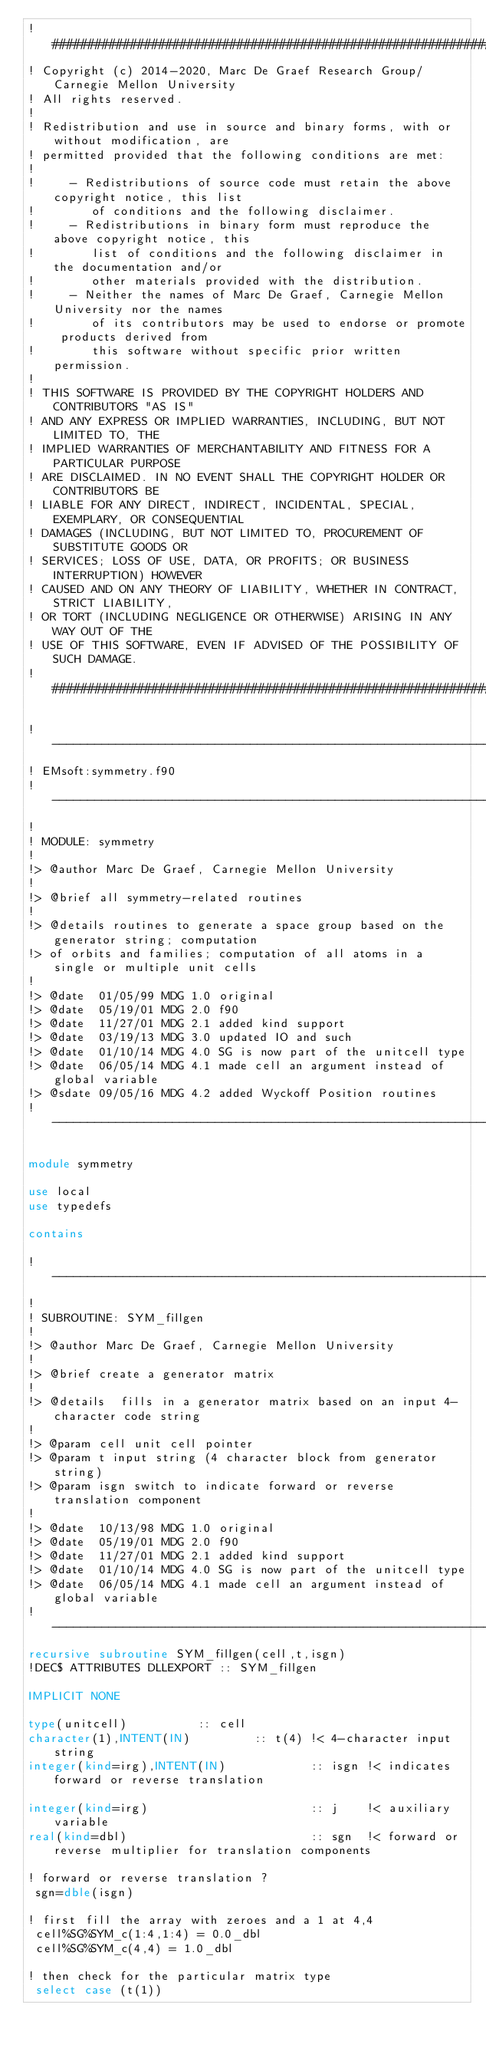<code> <loc_0><loc_0><loc_500><loc_500><_FORTRAN_>! ###################################################################
! Copyright (c) 2014-2020, Marc De Graef Research Group/Carnegie Mellon University
! All rights reserved.
!
! Redistribution and use in source and binary forms, with or without modification, are 
! permitted provided that the following conditions are met:
!
!     - Redistributions of source code must retain the above copyright notice, this list 
!        of conditions and the following disclaimer.
!     - Redistributions in binary form must reproduce the above copyright notice, this 
!        list of conditions and the following disclaimer in the documentation and/or 
!        other materials provided with the distribution.
!     - Neither the names of Marc De Graef, Carnegie Mellon University nor the names 
!        of its contributors may be used to endorse or promote products derived from 
!        this software without specific prior written permission.
!
! THIS SOFTWARE IS PROVIDED BY THE COPYRIGHT HOLDERS AND CONTRIBUTORS "AS IS" 
! AND ANY EXPRESS OR IMPLIED WARRANTIES, INCLUDING, BUT NOT LIMITED TO, THE 
! IMPLIED WARRANTIES OF MERCHANTABILITY AND FITNESS FOR A PARTICULAR PURPOSE 
! ARE DISCLAIMED. IN NO EVENT SHALL THE COPYRIGHT HOLDER OR CONTRIBUTORS BE 
! LIABLE FOR ANY DIRECT, INDIRECT, INCIDENTAL, SPECIAL, EXEMPLARY, OR CONSEQUENTIAL 
! DAMAGES (INCLUDING, BUT NOT LIMITED TO, PROCUREMENT OF SUBSTITUTE GOODS OR 
! SERVICES; LOSS OF USE, DATA, OR PROFITS; OR BUSINESS INTERRUPTION) HOWEVER 
! CAUSED AND ON ANY THEORY OF LIABILITY, WHETHER IN CONTRACT, STRICT LIABILITY, 
! OR TORT (INCLUDING NEGLIGENCE OR OTHERWISE) ARISING IN ANY WAY OUT OF THE 
! USE OF THIS SOFTWARE, EVEN IF ADVISED OF THE POSSIBILITY OF SUCH DAMAGE.
! ###################################################################

!--------------------------------------------------------------------------
! EMsoft:symmetry.f90
!--------------------------------------------------------------------------
!
! MODULE: symmetry
!
!> @author Marc De Graef, Carnegie Mellon University
!
!> @brief all symmetry-related routines
!
!> @details routines to generate a space group based on the generator string; computation
!> of orbits and families; computation of all atoms in a single or multiple unit cells
! 
!> @date  01/05/99 MDG 1.0 original
!> @date  05/19/01 MDG 2.0 f90
!> @date  11/27/01 MDG 2.1 added kind support
!> @date  03/19/13 MDG 3.0 updated IO and such
!> @date  01/10/14 MDG 4.0 SG is now part of the unitcell type
!> @date  06/05/14 MDG 4.1 made cell an argument instead of global variable 
!> @sdate 09/05/16 MDG 4.2 added Wyckoff Position routines
!--------------------------------------------------------------------------

module symmetry

use local
use typedefs

contains

!--------------------------------------------------------------------------
!
! SUBROUTINE: SYM_fillgen
!
!> @author Marc De Graef, Carnegie Mellon University
!
!> @brief create a generator matrix
!
!> @details  fills in a generator matrix based on an input 4-character code string
!
!> @param cell unit cell pointer
!> @param t input string (4 character block from generator string)
!> @param isgn switch to indicate forward or reverse translation component
!
!> @date  10/13/98 MDG 1.0 original
!> @date  05/19/01 MDG 2.0 f90
!> @date  11/27/01 MDG 2.1 added kind support
!> @date  01/10/14 MDG 4.0 SG is now part of the unitcell type
!> @date  06/05/14 MDG 4.1 made cell an argument instead of global variable 
!--------------------------------------------------------------------------
recursive subroutine SYM_fillgen(cell,t,isgn)
!DEC$ ATTRIBUTES DLLEXPORT :: SYM_fillgen

IMPLICIT NONE

type(unitcell)          :: cell
character(1),INTENT(IN)         :: t(4) !< 4-character input string
integer(kind=irg),INTENT(IN)            :: isgn !< indicates forward or reverse translation

integer(kind=irg)                       :: j    !< auxiliary variable
real(kind=dbl)                          :: sgn  !< forward or reverse multiplier for translation components

! forward or reverse translation ?
 sgn=dble(isgn)

! first fill the array with zeroes and a 1 at 4,4
 cell%SG%SYM_c(1:4,1:4) = 0.0_dbl
 cell%SG%SYM_c(4,4) = 1.0_dbl

! then check for the particular matrix type
 select case (t(1))</code> 